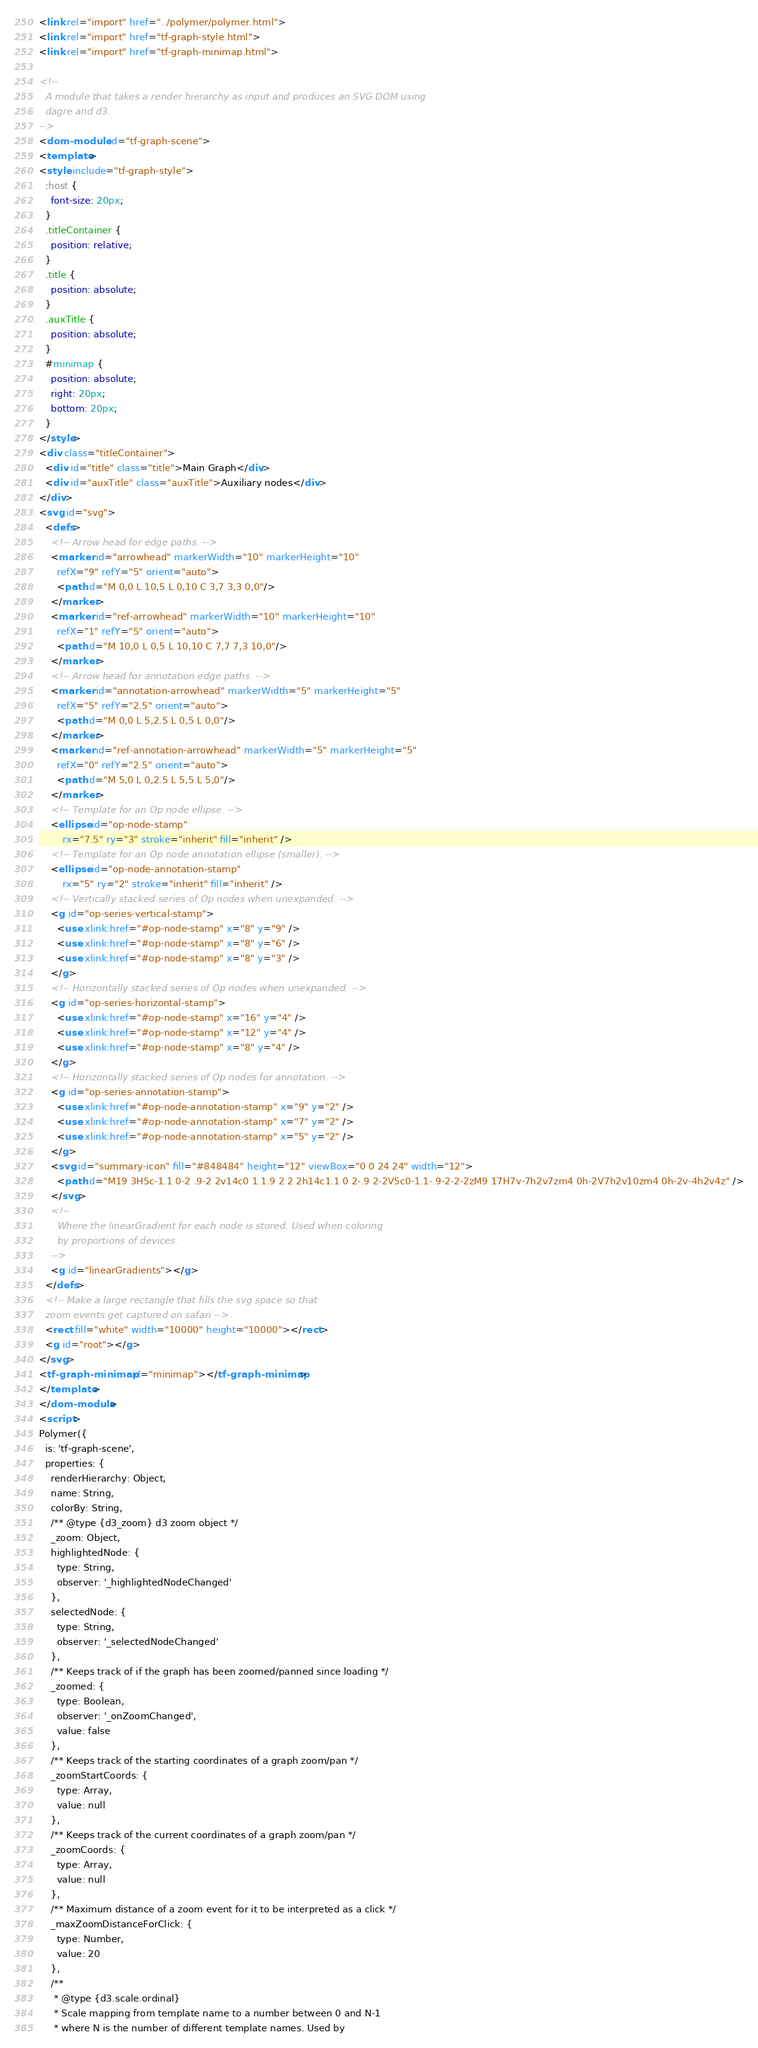<code> <loc_0><loc_0><loc_500><loc_500><_HTML_><link rel="import" href="../polymer/polymer.html">
<link rel="import" href="tf-graph-style.html">
<link rel="import" href="tf-graph-minimap.html">

<!--
  A module that takes a render hierarchy as input and produces an SVG DOM using
  dagre and d3.
-->
<dom-module id="tf-graph-scene">
<template>
<style include="tf-graph-style">
  :host {
    font-size: 20px;
  }
  .titleContainer {
    position: relative;
  }
  .title {
    position: absolute;
  }
  .auxTitle {
    position: absolute;
  }
  #minimap {
    position: absolute;
    right: 20px;
    bottom: 20px;
  }
</style>
<div class="titleContainer">
  <div id="title" class="title">Main Graph</div>
  <div id="auxTitle" class="auxTitle">Auxiliary nodes</div>
</div>
<svg id="svg">
  <defs>
    <!-- Arrow head for edge paths. -->
    <marker id="arrowhead" markerWidth="10" markerHeight="10"
      refX="9" refY="5" orient="auto">
      <path d="M 0,0 L 10,5 L 0,10 C 3,7 3,3 0,0"/>
    </marker>
    <marker id="ref-arrowhead" markerWidth="10" markerHeight="10"
      refX="1" refY="5" orient="auto">
      <path d="M 10,0 L 0,5 L 10,10 C 7,7 7,3 10,0"/>
    </marker>
    <!-- Arrow head for annotation edge paths. -->
    <marker id="annotation-arrowhead" markerWidth="5" markerHeight="5"
      refX="5" refY="2.5" orient="auto">
      <path d="M 0,0 L 5,2.5 L 0,5 L 0,0"/>
    </marker>
    <marker id="ref-annotation-arrowhead" markerWidth="5" markerHeight="5"
      refX="0" refY="2.5" orient="auto">
      <path d="M 5,0 L 0,2.5 L 5,5 L 5,0"/>
    </marker>
    <!-- Template for an Op node ellipse. -->
    <ellipse id="op-node-stamp"
        rx="7.5" ry="3" stroke="inherit" fill="inherit" />
    <!-- Template for an Op node annotation ellipse (smaller). -->
    <ellipse id="op-node-annotation-stamp"
        rx="5" ry="2" stroke="inherit" fill="inherit" />
    <!-- Vertically stacked series of Op nodes when unexpanded. -->
    <g id="op-series-vertical-stamp">
      <use xlink:href="#op-node-stamp" x="8" y="9" />
      <use xlink:href="#op-node-stamp" x="8" y="6" />
      <use xlink:href="#op-node-stamp" x="8" y="3" />
    </g>
    <!-- Horizontally stacked series of Op nodes when unexpanded. -->
    <g id="op-series-horizontal-stamp">
      <use xlink:href="#op-node-stamp" x="16" y="4" />
      <use xlink:href="#op-node-stamp" x="12" y="4" />
      <use xlink:href="#op-node-stamp" x="8" y="4" />
    </g>
    <!-- Horizontally stacked series of Op nodes for annotation. -->
    <g id="op-series-annotation-stamp">
      <use xlink:href="#op-node-annotation-stamp" x="9" y="2" />
      <use xlink:href="#op-node-annotation-stamp" x="7" y="2" />
      <use xlink:href="#op-node-annotation-stamp" x="5" y="2" />
    </g>
    <svg id="summary-icon" fill="#848484" height="12" viewBox="0 0 24 24" width="12">
      <path d="M19 3H5c-1.1 0-2 .9-2 2v14c0 1.1.9 2 2 2h14c1.1 0 2-.9 2-2V5c0-1.1-.9-2-2-2zM9 17H7v-7h2v7zm4 0h-2V7h2v10zm4 0h-2v-4h2v4z" />
    </svg>
    <!--
      Where the linearGradient for each node is stored. Used when coloring
      by proportions of devices.
    -->
    <g id="linearGradients"></g>
  </defs>
  <!-- Make a large rectangle that fills the svg space so that
  zoom events get captured on safari -->
  <rect fill="white" width="10000" height="10000"></rect>
  <g id="root"></g>
</svg>
<tf-graph-minimap id="minimap"></tf-graph-minimap>
</template>
</dom-module>
<script>
Polymer({
  is: 'tf-graph-scene',
  properties: {
    renderHierarchy: Object,
    name: String,
    colorBy: String,
    /** @type {d3_zoom} d3 zoom object */
    _zoom: Object,
    highlightedNode: {
      type: String,
      observer: '_highlightedNodeChanged'
    },
    selectedNode: {
      type: String,
      observer: '_selectedNodeChanged'
    },
    /** Keeps track of if the graph has been zoomed/panned since loading */
    _zoomed: {
      type: Boolean,
      observer: '_onZoomChanged',
      value: false
    },
    /** Keeps track of the starting coordinates of a graph zoom/pan */
    _zoomStartCoords: {
      type: Array,
      value: null
    },
    /** Keeps track of the current coordinates of a graph zoom/pan */
    _zoomCoords: {
      type: Array,
      value: null
    },
    /** Maximum distance of a zoom event for it to be interpreted as a click */
    _maxZoomDistanceForClick: {
      type: Number,
      value: 20
    },
    /**
     * @type {d3.scale.ordinal}
     * Scale mapping from template name to a number between 0 and N-1
     * where N is the number of different template names. Used by</code> 